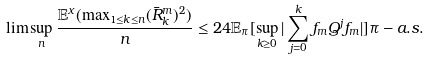<formula> <loc_0><loc_0><loc_500><loc_500>\lim \sup _ { n } \frac { \mathbb { E } ^ { x } ( \max _ { 1 \leq k \leq n } ( \bar { R } _ { k } ^ { m } ) ^ { 2 } ) } { n } \leq 2 4 \mathbb { E } _ { \pi } [ \sup _ { k \geq 0 } | \sum _ { j = 0 } ^ { k } f _ { m } Q ^ { j } f _ { m } | ] \pi - a . s .</formula> 